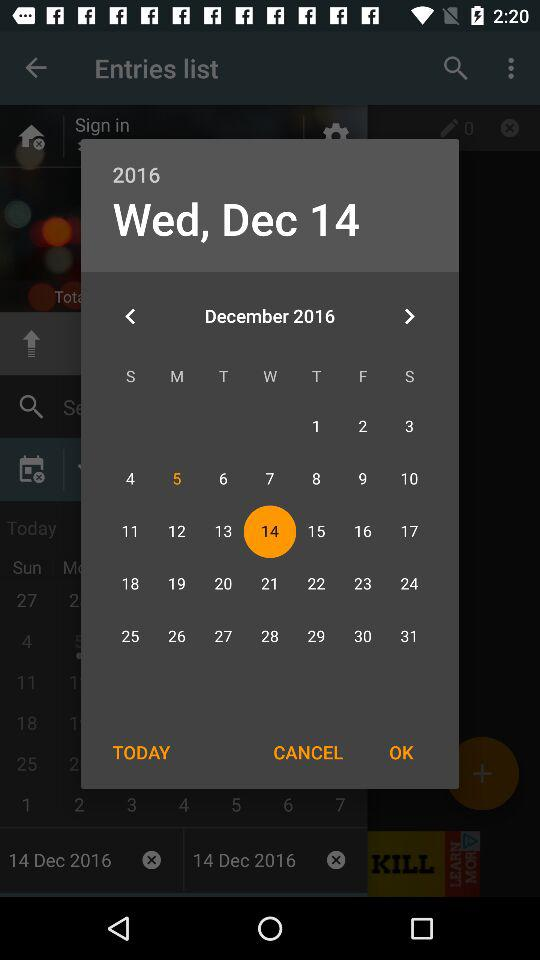What is the day and date? The day and date are Wednesday and December 14, 2016, respectively. 